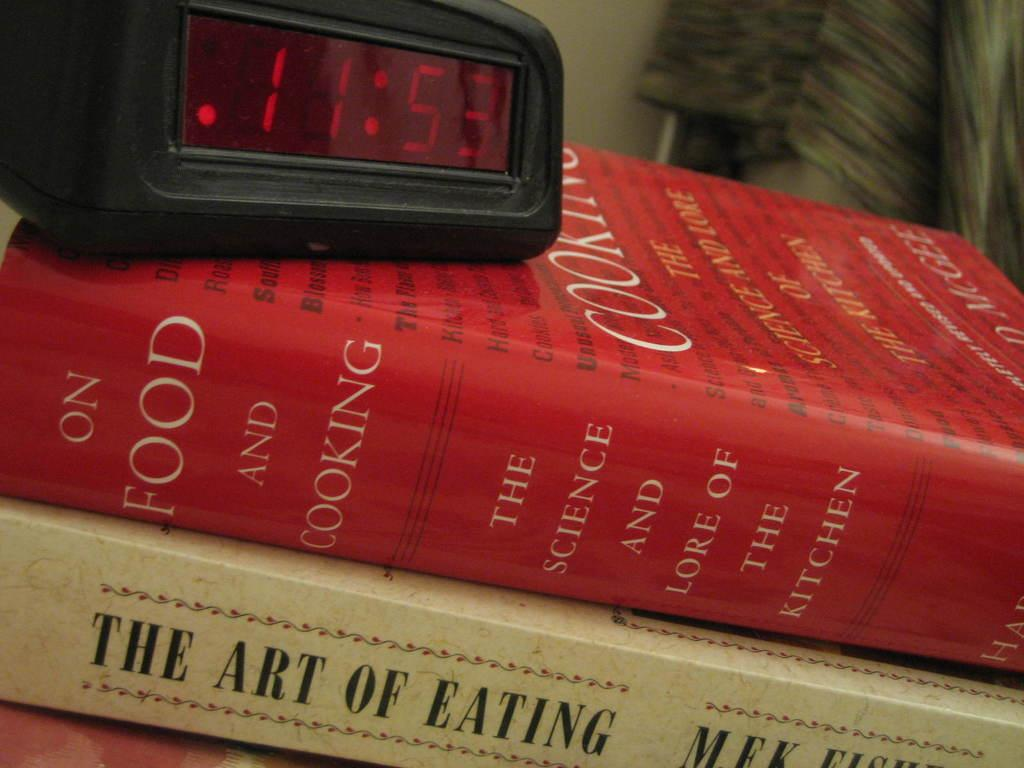Provide a one-sentence caption for the provided image. An alarm clock showing 11:53 is on a stack of books about cooking. 